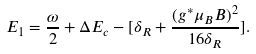Convert formula to latex. <formula><loc_0><loc_0><loc_500><loc_500>E _ { 1 } = \frac { { } \omega } { 2 } + \Delta E _ { c } - [ { \delta } _ { R } + \frac { ( { g ^ { * } \mu _ { B } B } ) ^ { 2 } } { 1 6 { \delta } _ { R } } ] .</formula> 